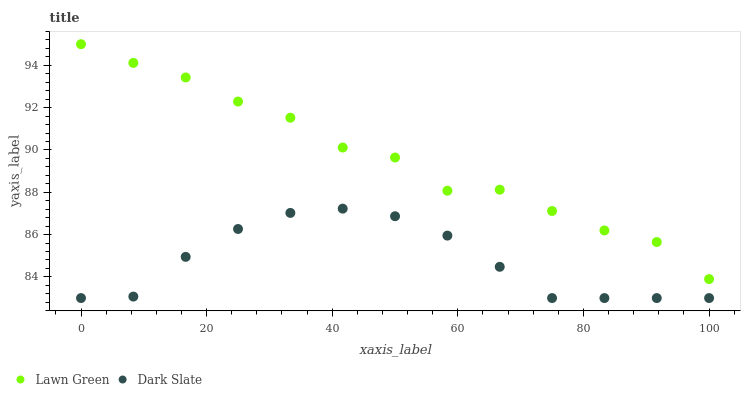Does Dark Slate have the minimum area under the curve?
Answer yes or no. Yes. Does Lawn Green have the maximum area under the curve?
Answer yes or no. Yes. Does Dark Slate have the maximum area under the curve?
Answer yes or no. No. Is Dark Slate the smoothest?
Answer yes or no. Yes. Is Lawn Green the roughest?
Answer yes or no. Yes. Is Dark Slate the roughest?
Answer yes or no. No. Does Dark Slate have the lowest value?
Answer yes or no. Yes. Does Lawn Green have the highest value?
Answer yes or no. Yes. Does Dark Slate have the highest value?
Answer yes or no. No. Is Dark Slate less than Lawn Green?
Answer yes or no. Yes. Is Lawn Green greater than Dark Slate?
Answer yes or no. Yes. Does Dark Slate intersect Lawn Green?
Answer yes or no. No. 